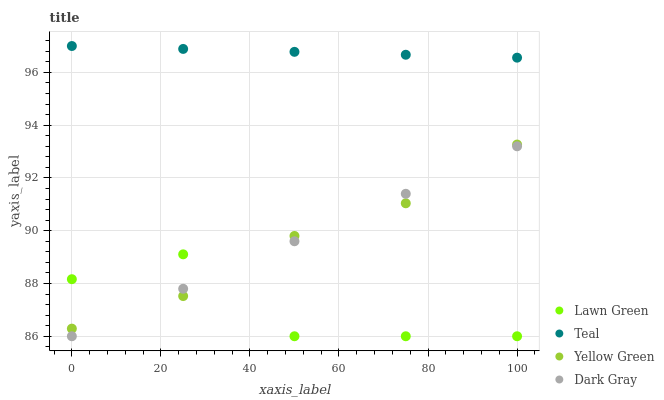Does Lawn Green have the minimum area under the curve?
Answer yes or no. Yes. Does Teal have the maximum area under the curve?
Answer yes or no. Yes. Does Yellow Green have the minimum area under the curve?
Answer yes or no. No. Does Yellow Green have the maximum area under the curve?
Answer yes or no. No. Is Teal the smoothest?
Answer yes or no. Yes. Is Lawn Green the roughest?
Answer yes or no. Yes. Is Yellow Green the smoothest?
Answer yes or no. No. Is Yellow Green the roughest?
Answer yes or no. No. Does Dark Gray have the lowest value?
Answer yes or no. Yes. Does Yellow Green have the lowest value?
Answer yes or no. No. Does Teal have the highest value?
Answer yes or no. Yes. Does Yellow Green have the highest value?
Answer yes or no. No. Is Lawn Green less than Teal?
Answer yes or no. Yes. Is Teal greater than Dark Gray?
Answer yes or no. Yes. Does Dark Gray intersect Yellow Green?
Answer yes or no. Yes. Is Dark Gray less than Yellow Green?
Answer yes or no. No. Is Dark Gray greater than Yellow Green?
Answer yes or no. No. Does Lawn Green intersect Teal?
Answer yes or no. No. 